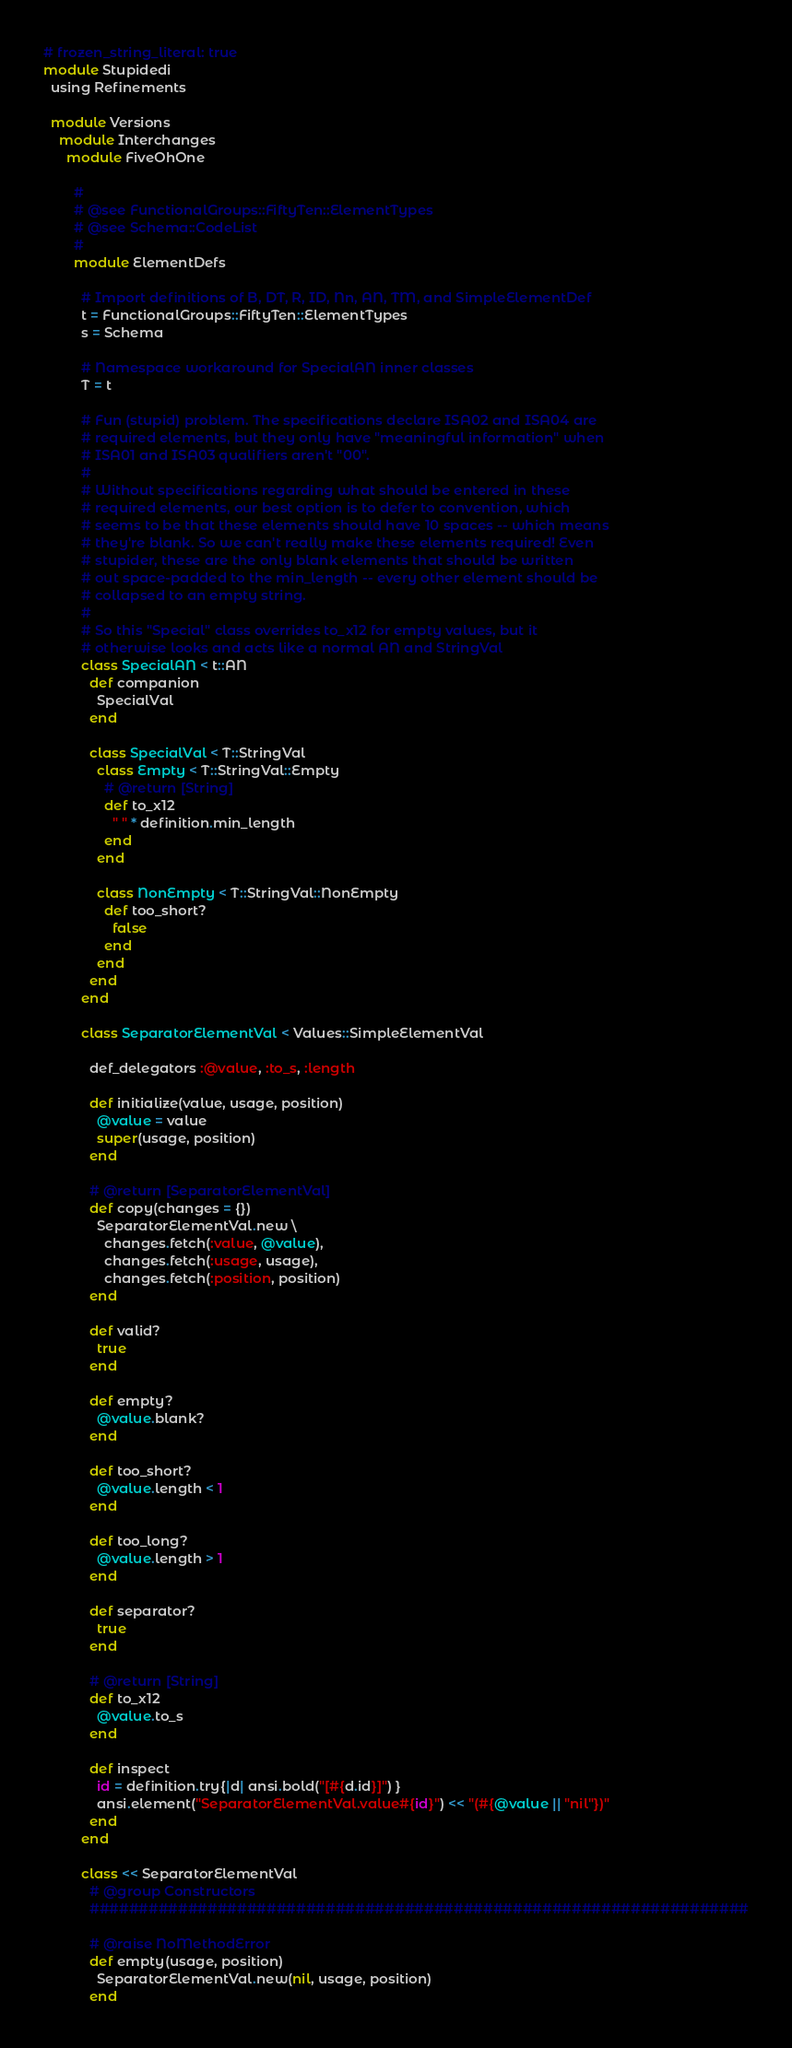Convert code to text. <code><loc_0><loc_0><loc_500><loc_500><_Ruby_># frozen_string_literal: true
module Stupidedi
  using Refinements

  module Versions
    module Interchanges
      module FiveOhOne

        #
        # @see FunctionalGroups::FiftyTen::ElementTypes
        # @see Schema::CodeList
        #
        module ElementDefs

          # Import definitions of B, DT, R, ID, Nn, AN, TM, and SimpleElementDef
          t = FunctionalGroups::FiftyTen::ElementTypes
          s = Schema

          # Namespace workaround for SpecialAN inner classes
          T = t

          # Fun (stupid) problem. The specifications declare ISA02 and ISA04 are
          # required elements, but they only have "meaningful information" when
          # ISA01 and ISA03 qualifiers aren't "00".
          #
          # Without specifications regarding what should be entered in these
          # required elements, our best option is to defer to convention, which
          # seems to be that these elements should have 10 spaces -- which means
          # they're blank. So we can't really make these elements required! Even
          # stupider, these are the only blank elements that should be written
          # out space-padded to the min_length -- every other element should be
          # collapsed to an empty string.
          #
          # So this "Special" class overrides to_x12 for empty values, but it
          # otherwise looks and acts like a normal AN and StringVal
          class SpecialAN < t::AN
            def companion
              SpecialVal
            end

            class SpecialVal < T::StringVal
              class Empty < T::StringVal::Empty
                # @return [String]
                def to_x12
                  " " * definition.min_length
                end
              end

              class NonEmpty < T::StringVal::NonEmpty
                def too_short?
                  false
                end
              end
            end
          end

          class SeparatorElementVal < Values::SimpleElementVal

            def_delegators :@value, :to_s, :length

            def initialize(value, usage, position)
              @value = value
              super(usage, position)
            end

            # @return [SeparatorElementVal]
            def copy(changes = {})
              SeparatorElementVal.new \
                changes.fetch(:value, @value),
                changes.fetch(:usage, usage),
                changes.fetch(:position, position)
            end

            def valid?
              true
            end

            def empty?
              @value.blank?
            end

            def too_short?
              @value.length < 1
            end

            def too_long?
              @value.length > 1
            end

            def separator?
              true
            end

            # @return [String]
            def to_x12
              @value.to_s
            end

            def inspect
              id = definition.try{|d| ansi.bold("[#{d.id}]") }
              ansi.element("SeparatorElementVal.value#{id}") << "(#{@value || "nil"})"
            end
          end

          class << SeparatorElementVal
            # @group Constructors
            ###################################################################

            # @raise NoMethodError
            def empty(usage, position)
              SeparatorElementVal.new(nil, usage, position)
            end
</code> 